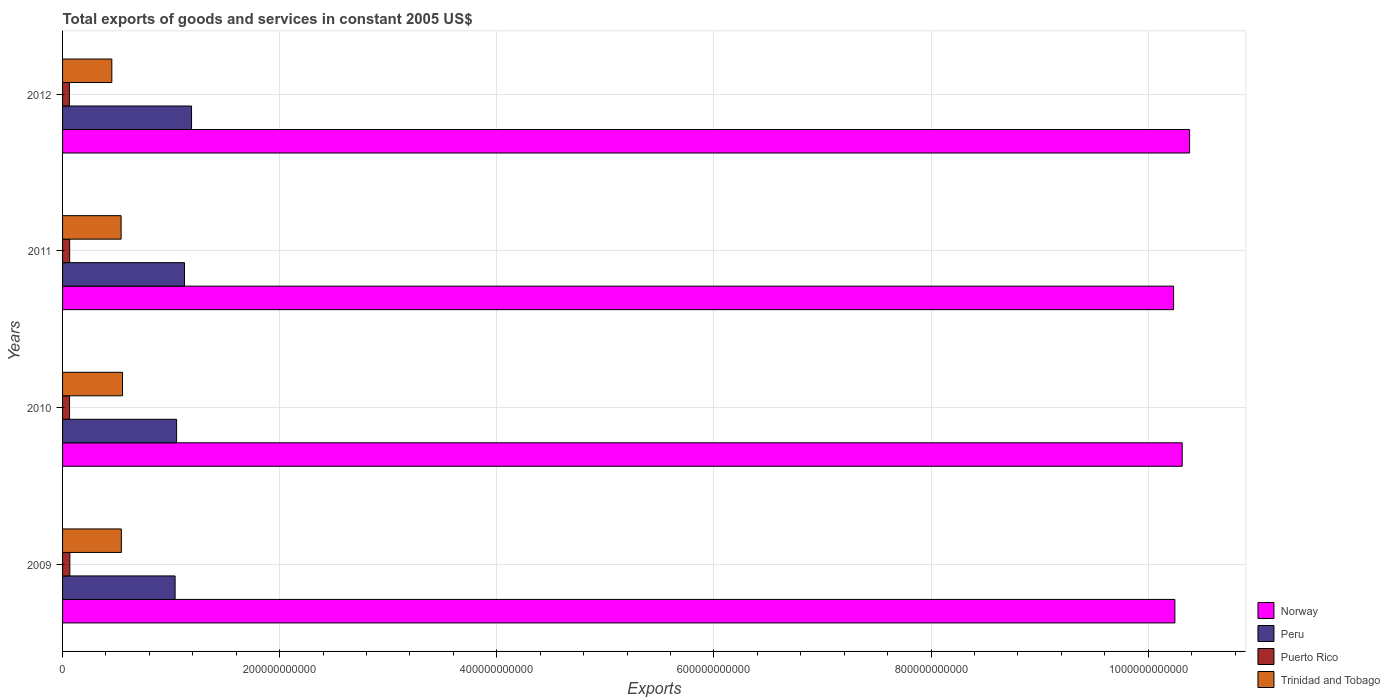How many different coloured bars are there?
Keep it short and to the point. 4. How many groups of bars are there?
Offer a terse response. 4. Are the number of bars on each tick of the Y-axis equal?
Your response must be concise. Yes. How many bars are there on the 1st tick from the bottom?
Keep it short and to the point. 4. What is the total exports of goods and services in Puerto Rico in 2011?
Keep it short and to the point. 6.55e+09. Across all years, what is the maximum total exports of goods and services in Norway?
Your answer should be very brief. 1.04e+12. Across all years, what is the minimum total exports of goods and services in Trinidad and Tobago?
Ensure brevity in your answer.  4.54e+1. What is the total total exports of goods and services in Trinidad and Tobago in the graph?
Ensure brevity in your answer.  2.09e+11. What is the difference between the total exports of goods and services in Peru in 2009 and that in 2012?
Your answer should be compact. -1.51e+1. What is the difference between the total exports of goods and services in Peru in 2010 and the total exports of goods and services in Trinidad and Tobago in 2012?
Make the answer very short. 5.97e+1. What is the average total exports of goods and services in Peru per year?
Your answer should be compact. 1.10e+11. In the year 2012, what is the difference between the total exports of goods and services in Puerto Rico and total exports of goods and services in Norway?
Your answer should be very brief. -1.03e+12. In how many years, is the total exports of goods and services in Puerto Rico greater than 40000000000 US$?
Your answer should be compact. 0. What is the ratio of the total exports of goods and services in Trinidad and Tobago in 2009 to that in 2011?
Provide a short and direct response. 1. Is the difference between the total exports of goods and services in Puerto Rico in 2010 and 2012 greater than the difference between the total exports of goods and services in Norway in 2010 and 2012?
Your response must be concise. Yes. What is the difference between the highest and the second highest total exports of goods and services in Norway?
Keep it short and to the point. 6.79e+09. What is the difference between the highest and the lowest total exports of goods and services in Puerto Rico?
Make the answer very short. 4.16e+08. What does the 3rd bar from the top in 2011 represents?
Give a very brief answer. Peru. What does the 1st bar from the bottom in 2010 represents?
Your answer should be compact. Norway. How many bars are there?
Your response must be concise. 16. What is the difference between two consecutive major ticks on the X-axis?
Offer a terse response. 2.00e+11. Does the graph contain any zero values?
Provide a succinct answer. No. Where does the legend appear in the graph?
Your answer should be very brief. Bottom right. How are the legend labels stacked?
Ensure brevity in your answer.  Vertical. What is the title of the graph?
Your response must be concise. Total exports of goods and services in constant 2005 US$. Does "Colombia" appear as one of the legend labels in the graph?
Your answer should be very brief. No. What is the label or title of the X-axis?
Provide a short and direct response. Exports. What is the label or title of the Y-axis?
Your answer should be very brief. Years. What is the Exports of Norway in 2009?
Ensure brevity in your answer.  1.02e+12. What is the Exports in Peru in 2009?
Provide a succinct answer. 1.04e+11. What is the Exports of Puerto Rico in 2009?
Offer a very short reply. 6.70e+09. What is the Exports of Trinidad and Tobago in 2009?
Your answer should be compact. 5.42e+1. What is the Exports in Norway in 2010?
Keep it short and to the point. 1.03e+12. What is the Exports of Peru in 2010?
Your answer should be very brief. 1.05e+11. What is the Exports of Puerto Rico in 2010?
Make the answer very short. 6.44e+09. What is the Exports of Trinidad and Tobago in 2010?
Give a very brief answer. 5.52e+1. What is the Exports of Norway in 2011?
Your response must be concise. 1.02e+12. What is the Exports of Peru in 2011?
Give a very brief answer. 1.12e+11. What is the Exports in Puerto Rico in 2011?
Offer a terse response. 6.55e+09. What is the Exports of Trinidad and Tobago in 2011?
Provide a succinct answer. 5.39e+1. What is the Exports in Norway in 2012?
Provide a short and direct response. 1.04e+12. What is the Exports of Peru in 2012?
Your response must be concise. 1.19e+11. What is the Exports of Puerto Rico in 2012?
Provide a succinct answer. 6.28e+09. What is the Exports of Trinidad and Tobago in 2012?
Keep it short and to the point. 4.54e+1. Across all years, what is the maximum Exports in Norway?
Keep it short and to the point. 1.04e+12. Across all years, what is the maximum Exports of Peru?
Keep it short and to the point. 1.19e+11. Across all years, what is the maximum Exports in Puerto Rico?
Your answer should be very brief. 6.70e+09. Across all years, what is the maximum Exports in Trinidad and Tobago?
Ensure brevity in your answer.  5.52e+1. Across all years, what is the minimum Exports of Norway?
Your answer should be very brief. 1.02e+12. Across all years, what is the minimum Exports of Peru?
Your answer should be compact. 1.04e+11. Across all years, what is the minimum Exports of Puerto Rico?
Offer a terse response. 6.28e+09. Across all years, what is the minimum Exports of Trinidad and Tobago?
Ensure brevity in your answer.  4.54e+1. What is the total Exports of Norway in the graph?
Give a very brief answer. 4.12e+12. What is the total Exports of Peru in the graph?
Your answer should be compact. 4.40e+11. What is the total Exports in Puerto Rico in the graph?
Your response must be concise. 2.60e+1. What is the total Exports of Trinidad and Tobago in the graph?
Your response must be concise. 2.09e+11. What is the difference between the Exports in Norway in 2009 and that in 2010?
Your response must be concise. -6.76e+09. What is the difference between the Exports of Peru in 2009 and that in 2010?
Your answer should be compact. -1.38e+09. What is the difference between the Exports in Puerto Rico in 2009 and that in 2010?
Offer a terse response. 2.59e+08. What is the difference between the Exports in Trinidad and Tobago in 2009 and that in 2010?
Make the answer very short. -1.08e+09. What is the difference between the Exports in Norway in 2009 and that in 2011?
Make the answer very short. 1.22e+09. What is the difference between the Exports of Peru in 2009 and that in 2011?
Your answer should be compact. -8.64e+09. What is the difference between the Exports of Puerto Rico in 2009 and that in 2011?
Give a very brief answer. 1.49e+08. What is the difference between the Exports of Trinidad and Tobago in 2009 and that in 2011?
Provide a short and direct response. 2.23e+08. What is the difference between the Exports in Norway in 2009 and that in 2012?
Ensure brevity in your answer.  -1.36e+1. What is the difference between the Exports of Peru in 2009 and that in 2012?
Ensure brevity in your answer.  -1.51e+1. What is the difference between the Exports of Puerto Rico in 2009 and that in 2012?
Your answer should be very brief. 4.16e+08. What is the difference between the Exports of Trinidad and Tobago in 2009 and that in 2012?
Offer a very short reply. 8.78e+09. What is the difference between the Exports of Norway in 2010 and that in 2011?
Provide a succinct answer. 7.98e+09. What is the difference between the Exports in Peru in 2010 and that in 2011?
Give a very brief answer. -7.27e+09. What is the difference between the Exports of Puerto Rico in 2010 and that in 2011?
Keep it short and to the point. -1.11e+08. What is the difference between the Exports of Trinidad and Tobago in 2010 and that in 2011?
Your response must be concise. 1.30e+09. What is the difference between the Exports of Norway in 2010 and that in 2012?
Your answer should be very brief. -6.79e+09. What is the difference between the Exports in Peru in 2010 and that in 2012?
Give a very brief answer. -1.38e+1. What is the difference between the Exports of Puerto Rico in 2010 and that in 2012?
Your answer should be compact. 1.57e+08. What is the difference between the Exports in Trinidad and Tobago in 2010 and that in 2012?
Your answer should be compact. 9.86e+09. What is the difference between the Exports in Norway in 2011 and that in 2012?
Give a very brief answer. -1.48e+1. What is the difference between the Exports of Peru in 2011 and that in 2012?
Provide a succinct answer. -6.51e+09. What is the difference between the Exports in Puerto Rico in 2011 and that in 2012?
Offer a very short reply. 2.68e+08. What is the difference between the Exports of Trinidad and Tobago in 2011 and that in 2012?
Provide a short and direct response. 8.56e+09. What is the difference between the Exports of Norway in 2009 and the Exports of Peru in 2010?
Offer a very short reply. 9.20e+11. What is the difference between the Exports of Norway in 2009 and the Exports of Puerto Rico in 2010?
Your answer should be compact. 1.02e+12. What is the difference between the Exports of Norway in 2009 and the Exports of Trinidad and Tobago in 2010?
Provide a succinct answer. 9.69e+11. What is the difference between the Exports of Peru in 2009 and the Exports of Puerto Rico in 2010?
Your answer should be compact. 9.72e+1. What is the difference between the Exports in Peru in 2009 and the Exports in Trinidad and Tobago in 2010?
Your answer should be very brief. 4.84e+1. What is the difference between the Exports in Puerto Rico in 2009 and the Exports in Trinidad and Tobago in 2010?
Offer a terse response. -4.85e+1. What is the difference between the Exports of Norway in 2009 and the Exports of Peru in 2011?
Offer a very short reply. 9.12e+11. What is the difference between the Exports of Norway in 2009 and the Exports of Puerto Rico in 2011?
Keep it short and to the point. 1.02e+12. What is the difference between the Exports of Norway in 2009 and the Exports of Trinidad and Tobago in 2011?
Provide a short and direct response. 9.71e+11. What is the difference between the Exports of Peru in 2009 and the Exports of Puerto Rico in 2011?
Keep it short and to the point. 9.71e+1. What is the difference between the Exports in Peru in 2009 and the Exports in Trinidad and Tobago in 2011?
Your answer should be compact. 4.97e+1. What is the difference between the Exports in Puerto Rico in 2009 and the Exports in Trinidad and Tobago in 2011?
Make the answer very short. -4.72e+1. What is the difference between the Exports in Norway in 2009 and the Exports in Peru in 2012?
Your answer should be very brief. 9.06e+11. What is the difference between the Exports in Norway in 2009 and the Exports in Puerto Rico in 2012?
Ensure brevity in your answer.  1.02e+12. What is the difference between the Exports in Norway in 2009 and the Exports in Trinidad and Tobago in 2012?
Keep it short and to the point. 9.79e+11. What is the difference between the Exports in Peru in 2009 and the Exports in Puerto Rico in 2012?
Offer a very short reply. 9.74e+1. What is the difference between the Exports in Peru in 2009 and the Exports in Trinidad and Tobago in 2012?
Give a very brief answer. 5.83e+1. What is the difference between the Exports in Puerto Rico in 2009 and the Exports in Trinidad and Tobago in 2012?
Ensure brevity in your answer.  -3.87e+1. What is the difference between the Exports in Norway in 2010 and the Exports in Peru in 2011?
Your response must be concise. 9.19e+11. What is the difference between the Exports in Norway in 2010 and the Exports in Puerto Rico in 2011?
Provide a succinct answer. 1.02e+12. What is the difference between the Exports in Norway in 2010 and the Exports in Trinidad and Tobago in 2011?
Provide a short and direct response. 9.77e+11. What is the difference between the Exports of Peru in 2010 and the Exports of Puerto Rico in 2011?
Offer a very short reply. 9.85e+1. What is the difference between the Exports of Peru in 2010 and the Exports of Trinidad and Tobago in 2011?
Make the answer very short. 5.11e+1. What is the difference between the Exports in Puerto Rico in 2010 and the Exports in Trinidad and Tobago in 2011?
Make the answer very short. -4.75e+1. What is the difference between the Exports of Norway in 2010 and the Exports of Peru in 2012?
Keep it short and to the point. 9.13e+11. What is the difference between the Exports in Norway in 2010 and the Exports in Puerto Rico in 2012?
Your answer should be compact. 1.03e+12. What is the difference between the Exports in Norway in 2010 and the Exports in Trinidad and Tobago in 2012?
Provide a short and direct response. 9.86e+11. What is the difference between the Exports of Peru in 2010 and the Exports of Puerto Rico in 2012?
Your answer should be very brief. 9.88e+1. What is the difference between the Exports of Peru in 2010 and the Exports of Trinidad and Tobago in 2012?
Your answer should be compact. 5.97e+1. What is the difference between the Exports in Puerto Rico in 2010 and the Exports in Trinidad and Tobago in 2012?
Your answer should be very brief. -3.89e+1. What is the difference between the Exports of Norway in 2011 and the Exports of Peru in 2012?
Offer a terse response. 9.05e+11. What is the difference between the Exports in Norway in 2011 and the Exports in Puerto Rico in 2012?
Your answer should be very brief. 1.02e+12. What is the difference between the Exports of Norway in 2011 and the Exports of Trinidad and Tobago in 2012?
Provide a short and direct response. 9.78e+11. What is the difference between the Exports in Peru in 2011 and the Exports in Puerto Rico in 2012?
Your answer should be compact. 1.06e+11. What is the difference between the Exports of Peru in 2011 and the Exports of Trinidad and Tobago in 2012?
Keep it short and to the point. 6.69e+1. What is the difference between the Exports in Puerto Rico in 2011 and the Exports in Trinidad and Tobago in 2012?
Keep it short and to the point. -3.88e+1. What is the average Exports of Norway per year?
Provide a short and direct response. 1.03e+12. What is the average Exports in Peru per year?
Your answer should be compact. 1.10e+11. What is the average Exports in Puerto Rico per year?
Keep it short and to the point. 6.49e+09. What is the average Exports in Trinidad and Tobago per year?
Your answer should be compact. 5.22e+1. In the year 2009, what is the difference between the Exports in Norway and Exports in Peru?
Offer a terse response. 9.21e+11. In the year 2009, what is the difference between the Exports in Norway and Exports in Puerto Rico?
Your answer should be very brief. 1.02e+12. In the year 2009, what is the difference between the Exports in Norway and Exports in Trinidad and Tobago?
Give a very brief answer. 9.70e+11. In the year 2009, what is the difference between the Exports of Peru and Exports of Puerto Rico?
Give a very brief answer. 9.70e+1. In the year 2009, what is the difference between the Exports of Peru and Exports of Trinidad and Tobago?
Offer a terse response. 4.95e+1. In the year 2009, what is the difference between the Exports in Puerto Rico and Exports in Trinidad and Tobago?
Make the answer very short. -4.75e+1. In the year 2010, what is the difference between the Exports in Norway and Exports in Peru?
Offer a very short reply. 9.26e+11. In the year 2010, what is the difference between the Exports of Norway and Exports of Puerto Rico?
Ensure brevity in your answer.  1.02e+12. In the year 2010, what is the difference between the Exports in Norway and Exports in Trinidad and Tobago?
Provide a short and direct response. 9.76e+11. In the year 2010, what is the difference between the Exports in Peru and Exports in Puerto Rico?
Offer a very short reply. 9.86e+1. In the year 2010, what is the difference between the Exports of Peru and Exports of Trinidad and Tobago?
Offer a very short reply. 4.98e+1. In the year 2010, what is the difference between the Exports of Puerto Rico and Exports of Trinidad and Tobago?
Your answer should be very brief. -4.88e+1. In the year 2011, what is the difference between the Exports in Norway and Exports in Peru?
Provide a short and direct response. 9.11e+11. In the year 2011, what is the difference between the Exports of Norway and Exports of Puerto Rico?
Your answer should be very brief. 1.02e+12. In the year 2011, what is the difference between the Exports of Norway and Exports of Trinidad and Tobago?
Your answer should be very brief. 9.69e+11. In the year 2011, what is the difference between the Exports in Peru and Exports in Puerto Rico?
Ensure brevity in your answer.  1.06e+11. In the year 2011, what is the difference between the Exports of Peru and Exports of Trinidad and Tobago?
Offer a terse response. 5.84e+1. In the year 2011, what is the difference between the Exports of Puerto Rico and Exports of Trinidad and Tobago?
Make the answer very short. -4.74e+1. In the year 2012, what is the difference between the Exports in Norway and Exports in Peru?
Keep it short and to the point. 9.19e+11. In the year 2012, what is the difference between the Exports in Norway and Exports in Puerto Rico?
Provide a succinct answer. 1.03e+12. In the year 2012, what is the difference between the Exports of Norway and Exports of Trinidad and Tobago?
Offer a terse response. 9.93e+11. In the year 2012, what is the difference between the Exports of Peru and Exports of Puerto Rico?
Your answer should be compact. 1.13e+11. In the year 2012, what is the difference between the Exports in Peru and Exports in Trinidad and Tobago?
Ensure brevity in your answer.  7.34e+1. In the year 2012, what is the difference between the Exports in Puerto Rico and Exports in Trinidad and Tobago?
Provide a short and direct response. -3.91e+1. What is the ratio of the Exports of Peru in 2009 to that in 2010?
Your answer should be very brief. 0.99. What is the ratio of the Exports in Puerto Rico in 2009 to that in 2010?
Offer a terse response. 1.04. What is the ratio of the Exports of Trinidad and Tobago in 2009 to that in 2010?
Your response must be concise. 0.98. What is the ratio of the Exports of Norway in 2009 to that in 2011?
Keep it short and to the point. 1. What is the ratio of the Exports in Peru in 2009 to that in 2011?
Your answer should be compact. 0.92. What is the ratio of the Exports in Puerto Rico in 2009 to that in 2011?
Provide a succinct answer. 1.02. What is the ratio of the Exports in Trinidad and Tobago in 2009 to that in 2011?
Make the answer very short. 1. What is the ratio of the Exports of Norway in 2009 to that in 2012?
Make the answer very short. 0.99. What is the ratio of the Exports in Peru in 2009 to that in 2012?
Give a very brief answer. 0.87. What is the ratio of the Exports of Puerto Rico in 2009 to that in 2012?
Provide a short and direct response. 1.07. What is the ratio of the Exports in Trinidad and Tobago in 2009 to that in 2012?
Give a very brief answer. 1.19. What is the ratio of the Exports in Norway in 2010 to that in 2011?
Provide a succinct answer. 1.01. What is the ratio of the Exports in Peru in 2010 to that in 2011?
Provide a short and direct response. 0.94. What is the ratio of the Exports in Puerto Rico in 2010 to that in 2011?
Ensure brevity in your answer.  0.98. What is the ratio of the Exports in Trinidad and Tobago in 2010 to that in 2011?
Offer a very short reply. 1.02. What is the ratio of the Exports in Norway in 2010 to that in 2012?
Give a very brief answer. 0.99. What is the ratio of the Exports in Peru in 2010 to that in 2012?
Provide a short and direct response. 0.88. What is the ratio of the Exports in Trinidad and Tobago in 2010 to that in 2012?
Your response must be concise. 1.22. What is the ratio of the Exports of Norway in 2011 to that in 2012?
Keep it short and to the point. 0.99. What is the ratio of the Exports of Peru in 2011 to that in 2012?
Provide a succinct answer. 0.95. What is the ratio of the Exports of Puerto Rico in 2011 to that in 2012?
Your answer should be very brief. 1.04. What is the ratio of the Exports of Trinidad and Tobago in 2011 to that in 2012?
Your answer should be compact. 1.19. What is the difference between the highest and the second highest Exports of Norway?
Provide a succinct answer. 6.79e+09. What is the difference between the highest and the second highest Exports of Peru?
Your response must be concise. 6.51e+09. What is the difference between the highest and the second highest Exports in Puerto Rico?
Ensure brevity in your answer.  1.49e+08. What is the difference between the highest and the second highest Exports in Trinidad and Tobago?
Make the answer very short. 1.08e+09. What is the difference between the highest and the lowest Exports of Norway?
Offer a terse response. 1.48e+1. What is the difference between the highest and the lowest Exports of Peru?
Keep it short and to the point. 1.51e+1. What is the difference between the highest and the lowest Exports of Puerto Rico?
Ensure brevity in your answer.  4.16e+08. What is the difference between the highest and the lowest Exports in Trinidad and Tobago?
Offer a terse response. 9.86e+09. 